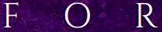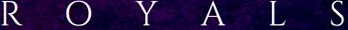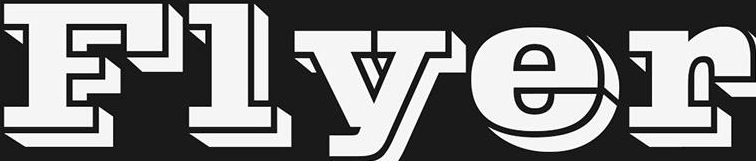Read the text from these images in sequence, separated by a semicolon. FOR; ROYALS; Flyer 